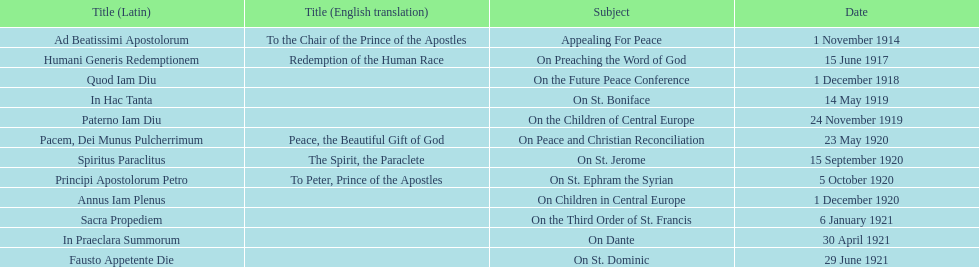What is the subject mentioned after calling for peace? On Preaching the Word of God. 